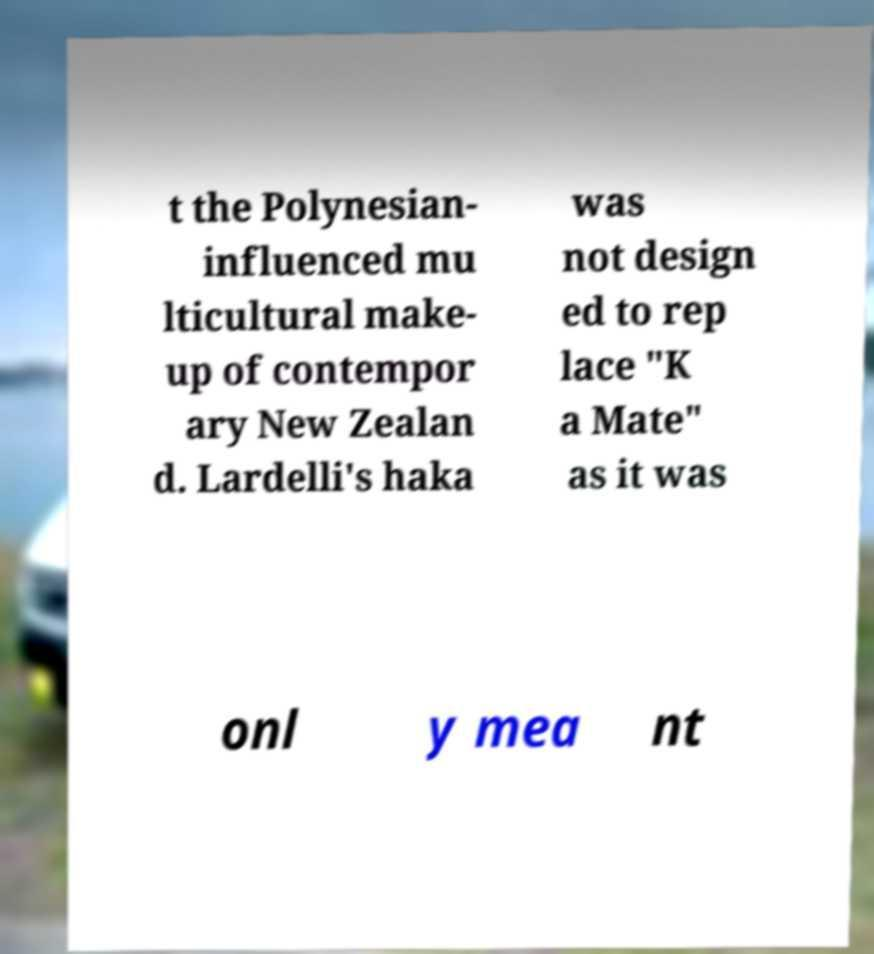What messages or text are displayed in this image? I need them in a readable, typed format. t the Polynesian- influenced mu lticultural make- up of contempor ary New Zealan d. Lardelli's haka was not design ed to rep lace "K a Mate" as it was onl y mea nt 